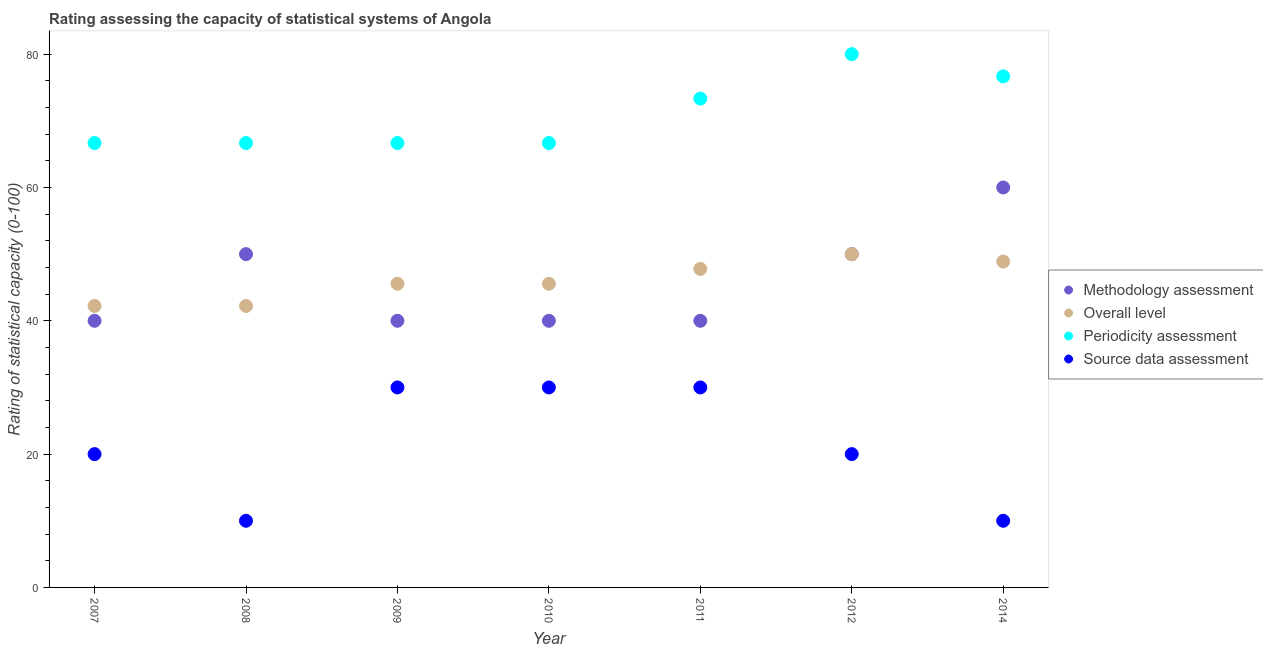How many different coloured dotlines are there?
Your response must be concise. 4. What is the methodology assessment rating in 2011?
Offer a terse response. 40. Across all years, what is the maximum source data assessment rating?
Ensure brevity in your answer.  30. Across all years, what is the minimum overall level rating?
Give a very brief answer. 42.22. In which year was the overall level rating maximum?
Provide a succinct answer. 2012. What is the total methodology assessment rating in the graph?
Offer a terse response. 320. What is the difference between the methodology assessment rating in 2011 and that in 2012?
Offer a very short reply. -10. What is the difference between the periodicity assessment rating in 2007 and the source data assessment rating in 2008?
Make the answer very short. 56.67. What is the average overall level rating per year?
Your answer should be compact. 46.03. In the year 2008, what is the difference between the overall level rating and methodology assessment rating?
Make the answer very short. -7.78. In how many years, is the periodicity assessment rating greater than 4?
Provide a short and direct response. 7. What is the ratio of the overall level rating in 2007 to that in 2009?
Provide a short and direct response. 0.93. Is the periodicity assessment rating in 2008 less than that in 2011?
Your response must be concise. Yes. Is the difference between the methodology assessment rating in 2011 and 2014 greater than the difference between the overall level rating in 2011 and 2014?
Provide a short and direct response. No. What is the difference between the highest and the lowest overall level rating?
Offer a terse response. 7.78. Is the sum of the overall level rating in 2008 and 2014 greater than the maximum periodicity assessment rating across all years?
Your answer should be compact. Yes. How many dotlines are there?
Offer a very short reply. 4. Does the graph contain any zero values?
Your answer should be very brief. No. Where does the legend appear in the graph?
Provide a succinct answer. Center right. How many legend labels are there?
Provide a succinct answer. 4. How are the legend labels stacked?
Provide a short and direct response. Vertical. What is the title of the graph?
Give a very brief answer. Rating assessing the capacity of statistical systems of Angola. Does "Corruption" appear as one of the legend labels in the graph?
Provide a succinct answer. No. What is the label or title of the Y-axis?
Your response must be concise. Rating of statistical capacity (0-100). What is the Rating of statistical capacity (0-100) in Methodology assessment in 2007?
Provide a short and direct response. 40. What is the Rating of statistical capacity (0-100) in Overall level in 2007?
Provide a succinct answer. 42.22. What is the Rating of statistical capacity (0-100) in Periodicity assessment in 2007?
Offer a very short reply. 66.67. What is the Rating of statistical capacity (0-100) of Overall level in 2008?
Make the answer very short. 42.22. What is the Rating of statistical capacity (0-100) in Periodicity assessment in 2008?
Give a very brief answer. 66.67. What is the Rating of statistical capacity (0-100) in Methodology assessment in 2009?
Make the answer very short. 40. What is the Rating of statistical capacity (0-100) in Overall level in 2009?
Your response must be concise. 45.56. What is the Rating of statistical capacity (0-100) in Periodicity assessment in 2009?
Your answer should be compact. 66.67. What is the Rating of statistical capacity (0-100) of Source data assessment in 2009?
Provide a short and direct response. 30. What is the Rating of statistical capacity (0-100) in Overall level in 2010?
Make the answer very short. 45.56. What is the Rating of statistical capacity (0-100) in Periodicity assessment in 2010?
Offer a terse response. 66.67. What is the Rating of statistical capacity (0-100) of Overall level in 2011?
Provide a succinct answer. 47.78. What is the Rating of statistical capacity (0-100) in Periodicity assessment in 2011?
Your answer should be very brief. 73.33. What is the Rating of statistical capacity (0-100) of Source data assessment in 2011?
Provide a short and direct response. 30. What is the Rating of statistical capacity (0-100) in Methodology assessment in 2012?
Provide a succinct answer. 50. What is the Rating of statistical capacity (0-100) in Periodicity assessment in 2012?
Keep it short and to the point. 80. What is the Rating of statistical capacity (0-100) of Methodology assessment in 2014?
Your answer should be compact. 60. What is the Rating of statistical capacity (0-100) in Overall level in 2014?
Ensure brevity in your answer.  48.89. What is the Rating of statistical capacity (0-100) of Periodicity assessment in 2014?
Ensure brevity in your answer.  76.67. Across all years, what is the maximum Rating of statistical capacity (0-100) of Methodology assessment?
Your answer should be compact. 60. Across all years, what is the minimum Rating of statistical capacity (0-100) of Methodology assessment?
Give a very brief answer. 40. Across all years, what is the minimum Rating of statistical capacity (0-100) of Overall level?
Provide a succinct answer. 42.22. Across all years, what is the minimum Rating of statistical capacity (0-100) of Periodicity assessment?
Make the answer very short. 66.67. Across all years, what is the minimum Rating of statistical capacity (0-100) in Source data assessment?
Ensure brevity in your answer.  10. What is the total Rating of statistical capacity (0-100) in Methodology assessment in the graph?
Offer a terse response. 320. What is the total Rating of statistical capacity (0-100) of Overall level in the graph?
Your answer should be compact. 322.22. What is the total Rating of statistical capacity (0-100) in Periodicity assessment in the graph?
Give a very brief answer. 496.67. What is the total Rating of statistical capacity (0-100) of Source data assessment in the graph?
Your answer should be very brief. 150. What is the difference between the Rating of statistical capacity (0-100) in Overall level in 2007 and that in 2008?
Make the answer very short. 0. What is the difference between the Rating of statistical capacity (0-100) in Source data assessment in 2007 and that in 2008?
Offer a terse response. 10. What is the difference between the Rating of statistical capacity (0-100) in Methodology assessment in 2007 and that in 2009?
Make the answer very short. 0. What is the difference between the Rating of statistical capacity (0-100) of Methodology assessment in 2007 and that in 2011?
Give a very brief answer. 0. What is the difference between the Rating of statistical capacity (0-100) of Overall level in 2007 and that in 2011?
Provide a short and direct response. -5.56. What is the difference between the Rating of statistical capacity (0-100) in Periodicity assessment in 2007 and that in 2011?
Your response must be concise. -6.67. What is the difference between the Rating of statistical capacity (0-100) of Source data assessment in 2007 and that in 2011?
Provide a short and direct response. -10. What is the difference between the Rating of statistical capacity (0-100) of Methodology assessment in 2007 and that in 2012?
Your answer should be very brief. -10. What is the difference between the Rating of statistical capacity (0-100) in Overall level in 2007 and that in 2012?
Keep it short and to the point. -7.78. What is the difference between the Rating of statistical capacity (0-100) of Periodicity assessment in 2007 and that in 2012?
Give a very brief answer. -13.33. What is the difference between the Rating of statistical capacity (0-100) in Source data assessment in 2007 and that in 2012?
Provide a short and direct response. 0. What is the difference between the Rating of statistical capacity (0-100) in Overall level in 2007 and that in 2014?
Provide a short and direct response. -6.67. What is the difference between the Rating of statistical capacity (0-100) of Source data assessment in 2007 and that in 2014?
Your answer should be very brief. 10. What is the difference between the Rating of statistical capacity (0-100) in Methodology assessment in 2008 and that in 2009?
Provide a succinct answer. 10. What is the difference between the Rating of statistical capacity (0-100) in Overall level in 2008 and that in 2009?
Keep it short and to the point. -3.33. What is the difference between the Rating of statistical capacity (0-100) of Methodology assessment in 2008 and that in 2010?
Offer a terse response. 10. What is the difference between the Rating of statistical capacity (0-100) of Overall level in 2008 and that in 2010?
Keep it short and to the point. -3.33. What is the difference between the Rating of statistical capacity (0-100) of Periodicity assessment in 2008 and that in 2010?
Your answer should be very brief. 0. What is the difference between the Rating of statistical capacity (0-100) of Overall level in 2008 and that in 2011?
Offer a terse response. -5.56. What is the difference between the Rating of statistical capacity (0-100) of Periodicity assessment in 2008 and that in 2011?
Keep it short and to the point. -6.67. What is the difference between the Rating of statistical capacity (0-100) of Methodology assessment in 2008 and that in 2012?
Ensure brevity in your answer.  0. What is the difference between the Rating of statistical capacity (0-100) of Overall level in 2008 and that in 2012?
Provide a succinct answer. -7.78. What is the difference between the Rating of statistical capacity (0-100) in Periodicity assessment in 2008 and that in 2012?
Your answer should be very brief. -13.33. What is the difference between the Rating of statistical capacity (0-100) of Overall level in 2008 and that in 2014?
Provide a succinct answer. -6.67. What is the difference between the Rating of statistical capacity (0-100) of Periodicity assessment in 2008 and that in 2014?
Give a very brief answer. -10. What is the difference between the Rating of statistical capacity (0-100) in Source data assessment in 2008 and that in 2014?
Your answer should be very brief. 0. What is the difference between the Rating of statistical capacity (0-100) of Methodology assessment in 2009 and that in 2010?
Provide a succinct answer. 0. What is the difference between the Rating of statistical capacity (0-100) of Periodicity assessment in 2009 and that in 2010?
Offer a very short reply. 0. What is the difference between the Rating of statistical capacity (0-100) in Overall level in 2009 and that in 2011?
Offer a terse response. -2.22. What is the difference between the Rating of statistical capacity (0-100) of Periodicity assessment in 2009 and that in 2011?
Your response must be concise. -6.67. What is the difference between the Rating of statistical capacity (0-100) in Source data assessment in 2009 and that in 2011?
Keep it short and to the point. 0. What is the difference between the Rating of statistical capacity (0-100) of Overall level in 2009 and that in 2012?
Provide a short and direct response. -4.44. What is the difference between the Rating of statistical capacity (0-100) of Periodicity assessment in 2009 and that in 2012?
Keep it short and to the point. -13.33. What is the difference between the Rating of statistical capacity (0-100) of Overall level in 2009 and that in 2014?
Your answer should be very brief. -3.33. What is the difference between the Rating of statistical capacity (0-100) in Periodicity assessment in 2009 and that in 2014?
Keep it short and to the point. -10. What is the difference between the Rating of statistical capacity (0-100) of Methodology assessment in 2010 and that in 2011?
Ensure brevity in your answer.  0. What is the difference between the Rating of statistical capacity (0-100) in Overall level in 2010 and that in 2011?
Offer a very short reply. -2.22. What is the difference between the Rating of statistical capacity (0-100) of Periodicity assessment in 2010 and that in 2011?
Make the answer very short. -6.67. What is the difference between the Rating of statistical capacity (0-100) of Methodology assessment in 2010 and that in 2012?
Your answer should be compact. -10. What is the difference between the Rating of statistical capacity (0-100) of Overall level in 2010 and that in 2012?
Give a very brief answer. -4.44. What is the difference between the Rating of statistical capacity (0-100) in Periodicity assessment in 2010 and that in 2012?
Your answer should be very brief. -13.33. What is the difference between the Rating of statistical capacity (0-100) of Overall level in 2010 and that in 2014?
Your answer should be compact. -3.33. What is the difference between the Rating of statistical capacity (0-100) in Overall level in 2011 and that in 2012?
Your answer should be very brief. -2.22. What is the difference between the Rating of statistical capacity (0-100) in Periodicity assessment in 2011 and that in 2012?
Keep it short and to the point. -6.67. What is the difference between the Rating of statistical capacity (0-100) of Overall level in 2011 and that in 2014?
Offer a terse response. -1.11. What is the difference between the Rating of statistical capacity (0-100) in Overall level in 2012 and that in 2014?
Your answer should be compact. 1.11. What is the difference between the Rating of statistical capacity (0-100) of Methodology assessment in 2007 and the Rating of statistical capacity (0-100) of Overall level in 2008?
Keep it short and to the point. -2.22. What is the difference between the Rating of statistical capacity (0-100) of Methodology assessment in 2007 and the Rating of statistical capacity (0-100) of Periodicity assessment in 2008?
Your response must be concise. -26.67. What is the difference between the Rating of statistical capacity (0-100) of Overall level in 2007 and the Rating of statistical capacity (0-100) of Periodicity assessment in 2008?
Make the answer very short. -24.44. What is the difference between the Rating of statistical capacity (0-100) in Overall level in 2007 and the Rating of statistical capacity (0-100) in Source data assessment in 2008?
Provide a short and direct response. 32.22. What is the difference between the Rating of statistical capacity (0-100) of Periodicity assessment in 2007 and the Rating of statistical capacity (0-100) of Source data assessment in 2008?
Give a very brief answer. 56.67. What is the difference between the Rating of statistical capacity (0-100) of Methodology assessment in 2007 and the Rating of statistical capacity (0-100) of Overall level in 2009?
Provide a succinct answer. -5.56. What is the difference between the Rating of statistical capacity (0-100) of Methodology assessment in 2007 and the Rating of statistical capacity (0-100) of Periodicity assessment in 2009?
Offer a very short reply. -26.67. What is the difference between the Rating of statistical capacity (0-100) of Methodology assessment in 2007 and the Rating of statistical capacity (0-100) of Source data assessment in 2009?
Offer a terse response. 10. What is the difference between the Rating of statistical capacity (0-100) of Overall level in 2007 and the Rating of statistical capacity (0-100) of Periodicity assessment in 2009?
Make the answer very short. -24.44. What is the difference between the Rating of statistical capacity (0-100) in Overall level in 2007 and the Rating of statistical capacity (0-100) in Source data assessment in 2009?
Provide a short and direct response. 12.22. What is the difference between the Rating of statistical capacity (0-100) in Periodicity assessment in 2007 and the Rating of statistical capacity (0-100) in Source data assessment in 2009?
Ensure brevity in your answer.  36.67. What is the difference between the Rating of statistical capacity (0-100) of Methodology assessment in 2007 and the Rating of statistical capacity (0-100) of Overall level in 2010?
Offer a very short reply. -5.56. What is the difference between the Rating of statistical capacity (0-100) of Methodology assessment in 2007 and the Rating of statistical capacity (0-100) of Periodicity assessment in 2010?
Keep it short and to the point. -26.67. What is the difference between the Rating of statistical capacity (0-100) of Overall level in 2007 and the Rating of statistical capacity (0-100) of Periodicity assessment in 2010?
Your answer should be very brief. -24.44. What is the difference between the Rating of statistical capacity (0-100) of Overall level in 2007 and the Rating of statistical capacity (0-100) of Source data assessment in 2010?
Your answer should be very brief. 12.22. What is the difference between the Rating of statistical capacity (0-100) in Periodicity assessment in 2007 and the Rating of statistical capacity (0-100) in Source data assessment in 2010?
Your response must be concise. 36.67. What is the difference between the Rating of statistical capacity (0-100) of Methodology assessment in 2007 and the Rating of statistical capacity (0-100) of Overall level in 2011?
Give a very brief answer. -7.78. What is the difference between the Rating of statistical capacity (0-100) of Methodology assessment in 2007 and the Rating of statistical capacity (0-100) of Periodicity assessment in 2011?
Your response must be concise. -33.33. What is the difference between the Rating of statistical capacity (0-100) in Methodology assessment in 2007 and the Rating of statistical capacity (0-100) in Source data assessment in 2011?
Give a very brief answer. 10. What is the difference between the Rating of statistical capacity (0-100) in Overall level in 2007 and the Rating of statistical capacity (0-100) in Periodicity assessment in 2011?
Your answer should be very brief. -31.11. What is the difference between the Rating of statistical capacity (0-100) of Overall level in 2007 and the Rating of statistical capacity (0-100) of Source data assessment in 2011?
Offer a very short reply. 12.22. What is the difference between the Rating of statistical capacity (0-100) of Periodicity assessment in 2007 and the Rating of statistical capacity (0-100) of Source data assessment in 2011?
Make the answer very short. 36.67. What is the difference between the Rating of statistical capacity (0-100) in Overall level in 2007 and the Rating of statistical capacity (0-100) in Periodicity assessment in 2012?
Keep it short and to the point. -37.78. What is the difference between the Rating of statistical capacity (0-100) of Overall level in 2007 and the Rating of statistical capacity (0-100) of Source data assessment in 2012?
Make the answer very short. 22.22. What is the difference between the Rating of statistical capacity (0-100) in Periodicity assessment in 2007 and the Rating of statistical capacity (0-100) in Source data assessment in 2012?
Ensure brevity in your answer.  46.67. What is the difference between the Rating of statistical capacity (0-100) of Methodology assessment in 2007 and the Rating of statistical capacity (0-100) of Overall level in 2014?
Provide a succinct answer. -8.89. What is the difference between the Rating of statistical capacity (0-100) in Methodology assessment in 2007 and the Rating of statistical capacity (0-100) in Periodicity assessment in 2014?
Offer a very short reply. -36.67. What is the difference between the Rating of statistical capacity (0-100) of Overall level in 2007 and the Rating of statistical capacity (0-100) of Periodicity assessment in 2014?
Your answer should be very brief. -34.44. What is the difference between the Rating of statistical capacity (0-100) of Overall level in 2007 and the Rating of statistical capacity (0-100) of Source data assessment in 2014?
Keep it short and to the point. 32.22. What is the difference between the Rating of statistical capacity (0-100) in Periodicity assessment in 2007 and the Rating of statistical capacity (0-100) in Source data assessment in 2014?
Give a very brief answer. 56.67. What is the difference between the Rating of statistical capacity (0-100) in Methodology assessment in 2008 and the Rating of statistical capacity (0-100) in Overall level in 2009?
Provide a short and direct response. 4.44. What is the difference between the Rating of statistical capacity (0-100) in Methodology assessment in 2008 and the Rating of statistical capacity (0-100) in Periodicity assessment in 2009?
Your answer should be very brief. -16.67. What is the difference between the Rating of statistical capacity (0-100) in Overall level in 2008 and the Rating of statistical capacity (0-100) in Periodicity assessment in 2009?
Ensure brevity in your answer.  -24.44. What is the difference between the Rating of statistical capacity (0-100) of Overall level in 2008 and the Rating of statistical capacity (0-100) of Source data assessment in 2009?
Keep it short and to the point. 12.22. What is the difference between the Rating of statistical capacity (0-100) in Periodicity assessment in 2008 and the Rating of statistical capacity (0-100) in Source data assessment in 2009?
Make the answer very short. 36.67. What is the difference between the Rating of statistical capacity (0-100) in Methodology assessment in 2008 and the Rating of statistical capacity (0-100) in Overall level in 2010?
Offer a very short reply. 4.44. What is the difference between the Rating of statistical capacity (0-100) of Methodology assessment in 2008 and the Rating of statistical capacity (0-100) of Periodicity assessment in 2010?
Your response must be concise. -16.67. What is the difference between the Rating of statistical capacity (0-100) of Methodology assessment in 2008 and the Rating of statistical capacity (0-100) of Source data assessment in 2010?
Offer a terse response. 20. What is the difference between the Rating of statistical capacity (0-100) of Overall level in 2008 and the Rating of statistical capacity (0-100) of Periodicity assessment in 2010?
Your answer should be very brief. -24.44. What is the difference between the Rating of statistical capacity (0-100) in Overall level in 2008 and the Rating of statistical capacity (0-100) in Source data assessment in 2010?
Give a very brief answer. 12.22. What is the difference between the Rating of statistical capacity (0-100) in Periodicity assessment in 2008 and the Rating of statistical capacity (0-100) in Source data assessment in 2010?
Your response must be concise. 36.67. What is the difference between the Rating of statistical capacity (0-100) of Methodology assessment in 2008 and the Rating of statistical capacity (0-100) of Overall level in 2011?
Your answer should be very brief. 2.22. What is the difference between the Rating of statistical capacity (0-100) of Methodology assessment in 2008 and the Rating of statistical capacity (0-100) of Periodicity assessment in 2011?
Make the answer very short. -23.33. What is the difference between the Rating of statistical capacity (0-100) in Overall level in 2008 and the Rating of statistical capacity (0-100) in Periodicity assessment in 2011?
Your answer should be compact. -31.11. What is the difference between the Rating of statistical capacity (0-100) of Overall level in 2008 and the Rating of statistical capacity (0-100) of Source data assessment in 2011?
Your answer should be compact. 12.22. What is the difference between the Rating of statistical capacity (0-100) in Periodicity assessment in 2008 and the Rating of statistical capacity (0-100) in Source data assessment in 2011?
Provide a short and direct response. 36.67. What is the difference between the Rating of statistical capacity (0-100) of Methodology assessment in 2008 and the Rating of statistical capacity (0-100) of Periodicity assessment in 2012?
Provide a succinct answer. -30. What is the difference between the Rating of statistical capacity (0-100) of Overall level in 2008 and the Rating of statistical capacity (0-100) of Periodicity assessment in 2012?
Provide a succinct answer. -37.78. What is the difference between the Rating of statistical capacity (0-100) of Overall level in 2008 and the Rating of statistical capacity (0-100) of Source data assessment in 2012?
Give a very brief answer. 22.22. What is the difference between the Rating of statistical capacity (0-100) of Periodicity assessment in 2008 and the Rating of statistical capacity (0-100) of Source data assessment in 2012?
Keep it short and to the point. 46.67. What is the difference between the Rating of statistical capacity (0-100) of Methodology assessment in 2008 and the Rating of statistical capacity (0-100) of Overall level in 2014?
Ensure brevity in your answer.  1.11. What is the difference between the Rating of statistical capacity (0-100) of Methodology assessment in 2008 and the Rating of statistical capacity (0-100) of Periodicity assessment in 2014?
Your answer should be very brief. -26.67. What is the difference between the Rating of statistical capacity (0-100) of Methodology assessment in 2008 and the Rating of statistical capacity (0-100) of Source data assessment in 2014?
Your response must be concise. 40. What is the difference between the Rating of statistical capacity (0-100) in Overall level in 2008 and the Rating of statistical capacity (0-100) in Periodicity assessment in 2014?
Give a very brief answer. -34.44. What is the difference between the Rating of statistical capacity (0-100) in Overall level in 2008 and the Rating of statistical capacity (0-100) in Source data assessment in 2014?
Your answer should be very brief. 32.22. What is the difference between the Rating of statistical capacity (0-100) of Periodicity assessment in 2008 and the Rating of statistical capacity (0-100) of Source data assessment in 2014?
Give a very brief answer. 56.67. What is the difference between the Rating of statistical capacity (0-100) of Methodology assessment in 2009 and the Rating of statistical capacity (0-100) of Overall level in 2010?
Ensure brevity in your answer.  -5.56. What is the difference between the Rating of statistical capacity (0-100) of Methodology assessment in 2009 and the Rating of statistical capacity (0-100) of Periodicity assessment in 2010?
Provide a succinct answer. -26.67. What is the difference between the Rating of statistical capacity (0-100) of Overall level in 2009 and the Rating of statistical capacity (0-100) of Periodicity assessment in 2010?
Give a very brief answer. -21.11. What is the difference between the Rating of statistical capacity (0-100) of Overall level in 2009 and the Rating of statistical capacity (0-100) of Source data assessment in 2010?
Ensure brevity in your answer.  15.56. What is the difference between the Rating of statistical capacity (0-100) in Periodicity assessment in 2009 and the Rating of statistical capacity (0-100) in Source data assessment in 2010?
Offer a terse response. 36.67. What is the difference between the Rating of statistical capacity (0-100) in Methodology assessment in 2009 and the Rating of statistical capacity (0-100) in Overall level in 2011?
Ensure brevity in your answer.  -7.78. What is the difference between the Rating of statistical capacity (0-100) in Methodology assessment in 2009 and the Rating of statistical capacity (0-100) in Periodicity assessment in 2011?
Keep it short and to the point. -33.33. What is the difference between the Rating of statistical capacity (0-100) in Methodology assessment in 2009 and the Rating of statistical capacity (0-100) in Source data assessment in 2011?
Your response must be concise. 10. What is the difference between the Rating of statistical capacity (0-100) of Overall level in 2009 and the Rating of statistical capacity (0-100) of Periodicity assessment in 2011?
Ensure brevity in your answer.  -27.78. What is the difference between the Rating of statistical capacity (0-100) in Overall level in 2009 and the Rating of statistical capacity (0-100) in Source data assessment in 2011?
Offer a terse response. 15.56. What is the difference between the Rating of statistical capacity (0-100) in Periodicity assessment in 2009 and the Rating of statistical capacity (0-100) in Source data assessment in 2011?
Give a very brief answer. 36.67. What is the difference between the Rating of statistical capacity (0-100) of Overall level in 2009 and the Rating of statistical capacity (0-100) of Periodicity assessment in 2012?
Make the answer very short. -34.44. What is the difference between the Rating of statistical capacity (0-100) in Overall level in 2009 and the Rating of statistical capacity (0-100) in Source data assessment in 2012?
Your answer should be very brief. 25.56. What is the difference between the Rating of statistical capacity (0-100) in Periodicity assessment in 2009 and the Rating of statistical capacity (0-100) in Source data assessment in 2012?
Your answer should be very brief. 46.67. What is the difference between the Rating of statistical capacity (0-100) in Methodology assessment in 2009 and the Rating of statistical capacity (0-100) in Overall level in 2014?
Ensure brevity in your answer.  -8.89. What is the difference between the Rating of statistical capacity (0-100) of Methodology assessment in 2009 and the Rating of statistical capacity (0-100) of Periodicity assessment in 2014?
Offer a very short reply. -36.67. What is the difference between the Rating of statistical capacity (0-100) in Overall level in 2009 and the Rating of statistical capacity (0-100) in Periodicity assessment in 2014?
Ensure brevity in your answer.  -31.11. What is the difference between the Rating of statistical capacity (0-100) in Overall level in 2009 and the Rating of statistical capacity (0-100) in Source data assessment in 2014?
Make the answer very short. 35.56. What is the difference between the Rating of statistical capacity (0-100) of Periodicity assessment in 2009 and the Rating of statistical capacity (0-100) of Source data assessment in 2014?
Provide a succinct answer. 56.67. What is the difference between the Rating of statistical capacity (0-100) in Methodology assessment in 2010 and the Rating of statistical capacity (0-100) in Overall level in 2011?
Your answer should be very brief. -7.78. What is the difference between the Rating of statistical capacity (0-100) in Methodology assessment in 2010 and the Rating of statistical capacity (0-100) in Periodicity assessment in 2011?
Provide a succinct answer. -33.33. What is the difference between the Rating of statistical capacity (0-100) of Overall level in 2010 and the Rating of statistical capacity (0-100) of Periodicity assessment in 2011?
Keep it short and to the point. -27.78. What is the difference between the Rating of statistical capacity (0-100) in Overall level in 2010 and the Rating of statistical capacity (0-100) in Source data assessment in 2011?
Offer a terse response. 15.56. What is the difference between the Rating of statistical capacity (0-100) in Periodicity assessment in 2010 and the Rating of statistical capacity (0-100) in Source data assessment in 2011?
Make the answer very short. 36.67. What is the difference between the Rating of statistical capacity (0-100) in Methodology assessment in 2010 and the Rating of statistical capacity (0-100) in Overall level in 2012?
Provide a succinct answer. -10. What is the difference between the Rating of statistical capacity (0-100) in Overall level in 2010 and the Rating of statistical capacity (0-100) in Periodicity assessment in 2012?
Give a very brief answer. -34.44. What is the difference between the Rating of statistical capacity (0-100) of Overall level in 2010 and the Rating of statistical capacity (0-100) of Source data assessment in 2012?
Give a very brief answer. 25.56. What is the difference between the Rating of statistical capacity (0-100) in Periodicity assessment in 2010 and the Rating of statistical capacity (0-100) in Source data assessment in 2012?
Provide a succinct answer. 46.67. What is the difference between the Rating of statistical capacity (0-100) in Methodology assessment in 2010 and the Rating of statistical capacity (0-100) in Overall level in 2014?
Keep it short and to the point. -8.89. What is the difference between the Rating of statistical capacity (0-100) of Methodology assessment in 2010 and the Rating of statistical capacity (0-100) of Periodicity assessment in 2014?
Give a very brief answer. -36.67. What is the difference between the Rating of statistical capacity (0-100) in Methodology assessment in 2010 and the Rating of statistical capacity (0-100) in Source data assessment in 2014?
Offer a very short reply. 30. What is the difference between the Rating of statistical capacity (0-100) of Overall level in 2010 and the Rating of statistical capacity (0-100) of Periodicity assessment in 2014?
Make the answer very short. -31.11. What is the difference between the Rating of statistical capacity (0-100) in Overall level in 2010 and the Rating of statistical capacity (0-100) in Source data assessment in 2014?
Make the answer very short. 35.56. What is the difference between the Rating of statistical capacity (0-100) in Periodicity assessment in 2010 and the Rating of statistical capacity (0-100) in Source data assessment in 2014?
Ensure brevity in your answer.  56.67. What is the difference between the Rating of statistical capacity (0-100) of Methodology assessment in 2011 and the Rating of statistical capacity (0-100) of Overall level in 2012?
Offer a very short reply. -10. What is the difference between the Rating of statistical capacity (0-100) in Methodology assessment in 2011 and the Rating of statistical capacity (0-100) in Source data assessment in 2012?
Offer a very short reply. 20. What is the difference between the Rating of statistical capacity (0-100) in Overall level in 2011 and the Rating of statistical capacity (0-100) in Periodicity assessment in 2012?
Make the answer very short. -32.22. What is the difference between the Rating of statistical capacity (0-100) in Overall level in 2011 and the Rating of statistical capacity (0-100) in Source data assessment in 2012?
Give a very brief answer. 27.78. What is the difference between the Rating of statistical capacity (0-100) in Periodicity assessment in 2011 and the Rating of statistical capacity (0-100) in Source data assessment in 2012?
Provide a succinct answer. 53.33. What is the difference between the Rating of statistical capacity (0-100) of Methodology assessment in 2011 and the Rating of statistical capacity (0-100) of Overall level in 2014?
Make the answer very short. -8.89. What is the difference between the Rating of statistical capacity (0-100) of Methodology assessment in 2011 and the Rating of statistical capacity (0-100) of Periodicity assessment in 2014?
Provide a short and direct response. -36.67. What is the difference between the Rating of statistical capacity (0-100) of Overall level in 2011 and the Rating of statistical capacity (0-100) of Periodicity assessment in 2014?
Your response must be concise. -28.89. What is the difference between the Rating of statistical capacity (0-100) of Overall level in 2011 and the Rating of statistical capacity (0-100) of Source data assessment in 2014?
Provide a short and direct response. 37.78. What is the difference between the Rating of statistical capacity (0-100) in Periodicity assessment in 2011 and the Rating of statistical capacity (0-100) in Source data assessment in 2014?
Keep it short and to the point. 63.33. What is the difference between the Rating of statistical capacity (0-100) of Methodology assessment in 2012 and the Rating of statistical capacity (0-100) of Periodicity assessment in 2014?
Offer a very short reply. -26.67. What is the difference between the Rating of statistical capacity (0-100) in Overall level in 2012 and the Rating of statistical capacity (0-100) in Periodicity assessment in 2014?
Ensure brevity in your answer.  -26.67. What is the difference between the Rating of statistical capacity (0-100) of Periodicity assessment in 2012 and the Rating of statistical capacity (0-100) of Source data assessment in 2014?
Your response must be concise. 70. What is the average Rating of statistical capacity (0-100) of Methodology assessment per year?
Provide a succinct answer. 45.71. What is the average Rating of statistical capacity (0-100) in Overall level per year?
Your response must be concise. 46.03. What is the average Rating of statistical capacity (0-100) in Periodicity assessment per year?
Make the answer very short. 70.95. What is the average Rating of statistical capacity (0-100) in Source data assessment per year?
Ensure brevity in your answer.  21.43. In the year 2007, what is the difference between the Rating of statistical capacity (0-100) in Methodology assessment and Rating of statistical capacity (0-100) in Overall level?
Offer a terse response. -2.22. In the year 2007, what is the difference between the Rating of statistical capacity (0-100) of Methodology assessment and Rating of statistical capacity (0-100) of Periodicity assessment?
Give a very brief answer. -26.67. In the year 2007, what is the difference between the Rating of statistical capacity (0-100) of Overall level and Rating of statistical capacity (0-100) of Periodicity assessment?
Give a very brief answer. -24.44. In the year 2007, what is the difference between the Rating of statistical capacity (0-100) of Overall level and Rating of statistical capacity (0-100) of Source data assessment?
Your answer should be compact. 22.22. In the year 2007, what is the difference between the Rating of statistical capacity (0-100) of Periodicity assessment and Rating of statistical capacity (0-100) of Source data assessment?
Provide a short and direct response. 46.67. In the year 2008, what is the difference between the Rating of statistical capacity (0-100) in Methodology assessment and Rating of statistical capacity (0-100) in Overall level?
Your response must be concise. 7.78. In the year 2008, what is the difference between the Rating of statistical capacity (0-100) of Methodology assessment and Rating of statistical capacity (0-100) of Periodicity assessment?
Offer a terse response. -16.67. In the year 2008, what is the difference between the Rating of statistical capacity (0-100) of Methodology assessment and Rating of statistical capacity (0-100) of Source data assessment?
Ensure brevity in your answer.  40. In the year 2008, what is the difference between the Rating of statistical capacity (0-100) of Overall level and Rating of statistical capacity (0-100) of Periodicity assessment?
Give a very brief answer. -24.44. In the year 2008, what is the difference between the Rating of statistical capacity (0-100) in Overall level and Rating of statistical capacity (0-100) in Source data assessment?
Keep it short and to the point. 32.22. In the year 2008, what is the difference between the Rating of statistical capacity (0-100) of Periodicity assessment and Rating of statistical capacity (0-100) of Source data assessment?
Make the answer very short. 56.67. In the year 2009, what is the difference between the Rating of statistical capacity (0-100) of Methodology assessment and Rating of statistical capacity (0-100) of Overall level?
Make the answer very short. -5.56. In the year 2009, what is the difference between the Rating of statistical capacity (0-100) in Methodology assessment and Rating of statistical capacity (0-100) in Periodicity assessment?
Your answer should be compact. -26.67. In the year 2009, what is the difference between the Rating of statistical capacity (0-100) in Overall level and Rating of statistical capacity (0-100) in Periodicity assessment?
Ensure brevity in your answer.  -21.11. In the year 2009, what is the difference between the Rating of statistical capacity (0-100) in Overall level and Rating of statistical capacity (0-100) in Source data assessment?
Offer a very short reply. 15.56. In the year 2009, what is the difference between the Rating of statistical capacity (0-100) of Periodicity assessment and Rating of statistical capacity (0-100) of Source data assessment?
Your answer should be compact. 36.67. In the year 2010, what is the difference between the Rating of statistical capacity (0-100) in Methodology assessment and Rating of statistical capacity (0-100) in Overall level?
Your answer should be very brief. -5.56. In the year 2010, what is the difference between the Rating of statistical capacity (0-100) in Methodology assessment and Rating of statistical capacity (0-100) in Periodicity assessment?
Offer a very short reply. -26.67. In the year 2010, what is the difference between the Rating of statistical capacity (0-100) in Methodology assessment and Rating of statistical capacity (0-100) in Source data assessment?
Offer a very short reply. 10. In the year 2010, what is the difference between the Rating of statistical capacity (0-100) of Overall level and Rating of statistical capacity (0-100) of Periodicity assessment?
Offer a terse response. -21.11. In the year 2010, what is the difference between the Rating of statistical capacity (0-100) in Overall level and Rating of statistical capacity (0-100) in Source data assessment?
Ensure brevity in your answer.  15.56. In the year 2010, what is the difference between the Rating of statistical capacity (0-100) in Periodicity assessment and Rating of statistical capacity (0-100) in Source data assessment?
Your response must be concise. 36.67. In the year 2011, what is the difference between the Rating of statistical capacity (0-100) of Methodology assessment and Rating of statistical capacity (0-100) of Overall level?
Offer a very short reply. -7.78. In the year 2011, what is the difference between the Rating of statistical capacity (0-100) in Methodology assessment and Rating of statistical capacity (0-100) in Periodicity assessment?
Make the answer very short. -33.33. In the year 2011, what is the difference between the Rating of statistical capacity (0-100) of Methodology assessment and Rating of statistical capacity (0-100) of Source data assessment?
Ensure brevity in your answer.  10. In the year 2011, what is the difference between the Rating of statistical capacity (0-100) of Overall level and Rating of statistical capacity (0-100) of Periodicity assessment?
Make the answer very short. -25.56. In the year 2011, what is the difference between the Rating of statistical capacity (0-100) in Overall level and Rating of statistical capacity (0-100) in Source data assessment?
Provide a succinct answer. 17.78. In the year 2011, what is the difference between the Rating of statistical capacity (0-100) of Periodicity assessment and Rating of statistical capacity (0-100) of Source data assessment?
Provide a short and direct response. 43.33. In the year 2014, what is the difference between the Rating of statistical capacity (0-100) of Methodology assessment and Rating of statistical capacity (0-100) of Overall level?
Offer a terse response. 11.11. In the year 2014, what is the difference between the Rating of statistical capacity (0-100) in Methodology assessment and Rating of statistical capacity (0-100) in Periodicity assessment?
Provide a short and direct response. -16.67. In the year 2014, what is the difference between the Rating of statistical capacity (0-100) in Methodology assessment and Rating of statistical capacity (0-100) in Source data assessment?
Keep it short and to the point. 50. In the year 2014, what is the difference between the Rating of statistical capacity (0-100) of Overall level and Rating of statistical capacity (0-100) of Periodicity assessment?
Your answer should be very brief. -27.78. In the year 2014, what is the difference between the Rating of statistical capacity (0-100) in Overall level and Rating of statistical capacity (0-100) in Source data assessment?
Offer a terse response. 38.89. In the year 2014, what is the difference between the Rating of statistical capacity (0-100) in Periodicity assessment and Rating of statistical capacity (0-100) in Source data assessment?
Offer a very short reply. 66.67. What is the ratio of the Rating of statistical capacity (0-100) of Methodology assessment in 2007 to that in 2008?
Your response must be concise. 0.8. What is the ratio of the Rating of statistical capacity (0-100) of Overall level in 2007 to that in 2008?
Your answer should be compact. 1. What is the ratio of the Rating of statistical capacity (0-100) in Periodicity assessment in 2007 to that in 2008?
Offer a terse response. 1. What is the ratio of the Rating of statistical capacity (0-100) in Source data assessment in 2007 to that in 2008?
Provide a short and direct response. 2. What is the ratio of the Rating of statistical capacity (0-100) in Overall level in 2007 to that in 2009?
Provide a succinct answer. 0.93. What is the ratio of the Rating of statistical capacity (0-100) in Periodicity assessment in 2007 to that in 2009?
Your answer should be very brief. 1. What is the ratio of the Rating of statistical capacity (0-100) in Source data assessment in 2007 to that in 2009?
Provide a short and direct response. 0.67. What is the ratio of the Rating of statistical capacity (0-100) in Methodology assessment in 2007 to that in 2010?
Give a very brief answer. 1. What is the ratio of the Rating of statistical capacity (0-100) of Overall level in 2007 to that in 2010?
Provide a short and direct response. 0.93. What is the ratio of the Rating of statistical capacity (0-100) of Periodicity assessment in 2007 to that in 2010?
Your response must be concise. 1. What is the ratio of the Rating of statistical capacity (0-100) of Source data assessment in 2007 to that in 2010?
Provide a short and direct response. 0.67. What is the ratio of the Rating of statistical capacity (0-100) of Methodology assessment in 2007 to that in 2011?
Make the answer very short. 1. What is the ratio of the Rating of statistical capacity (0-100) of Overall level in 2007 to that in 2011?
Provide a succinct answer. 0.88. What is the ratio of the Rating of statistical capacity (0-100) of Periodicity assessment in 2007 to that in 2011?
Offer a very short reply. 0.91. What is the ratio of the Rating of statistical capacity (0-100) of Source data assessment in 2007 to that in 2011?
Keep it short and to the point. 0.67. What is the ratio of the Rating of statistical capacity (0-100) in Methodology assessment in 2007 to that in 2012?
Offer a terse response. 0.8. What is the ratio of the Rating of statistical capacity (0-100) in Overall level in 2007 to that in 2012?
Offer a very short reply. 0.84. What is the ratio of the Rating of statistical capacity (0-100) of Periodicity assessment in 2007 to that in 2012?
Your answer should be very brief. 0.83. What is the ratio of the Rating of statistical capacity (0-100) in Overall level in 2007 to that in 2014?
Make the answer very short. 0.86. What is the ratio of the Rating of statistical capacity (0-100) of Periodicity assessment in 2007 to that in 2014?
Ensure brevity in your answer.  0.87. What is the ratio of the Rating of statistical capacity (0-100) of Overall level in 2008 to that in 2009?
Keep it short and to the point. 0.93. What is the ratio of the Rating of statistical capacity (0-100) of Periodicity assessment in 2008 to that in 2009?
Make the answer very short. 1. What is the ratio of the Rating of statistical capacity (0-100) of Methodology assessment in 2008 to that in 2010?
Your answer should be very brief. 1.25. What is the ratio of the Rating of statistical capacity (0-100) in Overall level in 2008 to that in 2010?
Give a very brief answer. 0.93. What is the ratio of the Rating of statistical capacity (0-100) in Periodicity assessment in 2008 to that in 2010?
Provide a short and direct response. 1. What is the ratio of the Rating of statistical capacity (0-100) in Source data assessment in 2008 to that in 2010?
Provide a short and direct response. 0.33. What is the ratio of the Rating of statistical capacity (0-100) of Methodology assessment in 2008 to that in 2011?
Make the answer very short. 1.25. What is the ratio of the Rating of statistical capacity (0-100) in Overall level in 2008 to that in 2011?
Provide a succinct answer. 0.88. What is the ratio of the Rating of statistical capacity (0-100) in Periodicity assessment in 2008 to that in 2011?
Give a very brief answer. 0.91. What is the ratio of the Rating of statistical capacity (0-100) of Overall level in 2008 to that in 2012?
Your answer should be very brief. 0.84. What is the ratio of the Rating of statistical capacity (0-100) of Methodology assessment in 2008 to that in 2014?
Give a very brief answer. 0.83. What is the ratio of the Rating of statistical capacity (0-100) in Overall level in 2008 to that in 2014?
Offer a terse response. 0.86. What is the ratio of the Rating of statistical capacity (0-100) in Periodicity assessment in 2008 to that in 2014?
Provide a succinct answer. 0.87. What is the ratio of the Rating of statistical capacity (0-100) of Methodology assessment in 2009 to that in 2010?
Offer a very short reply. 1. What is the ratio of the Rating of statistical capacity (0-100) in Periodicity assessment in 2009 to that in 2010?
Your response must be concise. 1. What is the ratio of the Rating of statistical capacity (0-100) of Methodology assessment in 2009 to that in 2011?
Provide a succinct answer. 1. What is the ratio of the Rating of statistical capacity (0-100) in Overall level in 2009 to that in 2011?
Your answer should be very brief. 0.95. What is the ratio of the Rating of statistical capacity (0-100) in Overall level in 2009 to that in 2012?
Keep it short and to the point. 0.91. What is the ratio of the Rating of statistical capacity (0-100) of Periodicity assessment in 2009 to that in 2012?
Ensure brevity in your answer.  0.83. What is the ratio of the Rating of statistical capacity (0-100) of Overall level in 2009 to that in 2014?
Ensure brevity in your answer.  0.93. What is the ratio of the Rating of statistical capacity (0-100) in Periodicity assessment in 2009 to that in 2014?
Your response must be concise. 0.87. What is the ratio of the Rating of statistical capacity (0-100) of Source data assessment in 2009 to that in 2014?
Offer a very short reply. 3. What is the ratio of the Rating of statistical capacity (0-100) of Methodology assessment in 2010 to that in 2011?
Offer a very short reply. 1. What is the ratio of the Rating of statistical capacity (0-100) in Overall level in 2010 to that in 2011?
Make the answer very short. 0.95. What is the ratio of the Rating of statistical capacity (0-100) in Methodology assessment in 2010 to that in 2012?
Make the answer very short. 0.8. What is the ratio of the Rating of statistical capacity (0-100) of Overall level in 2010 to that in 2012?
Give a very brief answer. 0.91. What is the ratio of the Rating of statistical capacity (0-100) in Periodicity assessment in 2010 to that in 2012?
Provide a short and direct response. 0.83. What is the ratio of the Rating of statistical capacity (0-100) in Methodology assessment in 2010 to that in 2014?
Provide a short and direct response. 0.67. What is the ratio of the Rating of statistical capacity (0-100) in Overall level in 2010 to that in 2014?
Offer a very short reply. 0.93. What is the ratio of the Rating of statistical capacity (0-100) of Periodicity assessment in 2010 to that in 2014?
Provide a short and direct response. 0.87. What is the ratio of the Rating of statistical capacity (0-100) of Source data assessment in 2010 to that in 2014?
Offer a very short reply. 3. What is the ratio of the Rating of statistical capacity (0-100) of Methodology assessment in 2011 to that in 2012?
Provide a succinct answer. 0.8. What is the ratio of the Rating of statistical capacity (0-100) in Overall level in 2011 to that in 2012?
Provide a short and direct response. 0.96. What is the ratio of the Rating of statistical capacity (0-100) of Overall level in 2011 to that in 2014?
Offer a very short reply. 0.98. What is the ratio of the Rating of statistical capacity (0-100) of Periodicity assessment in 2011 to that in 2014?
Your answer should be very brief. 0.96. What is the ratio of the Rating of statistical capacity (0-100) in Methodology assessment in 2012 to that in 2014?
Keep it short and to the point. 0.83. What is the ratio of the Rating of statistical capacity (0-100) of Overall level in 2012 to that in 2014?
Make the answer very short. 1.02. What is the ratio of the Rating of statistical capacity (0-100) of Periodicity assessment in 2012 to that in 2014?
Provide a short and direct response. 1.04. What is the difference between the highest and the second highest Rating of statistical capacity (0-100) of Overall level?
Offer a terse response. 1.11. What is the difference between the highest and the lowest Rating of statistical capacity (0-100) of Methodology assessment?
Offer a terse response. 20. What is the difference between the highest and the lowest Rating of statistical capacity (0-100) in Overall level?
Ensure brevity in your answer.  7.78. What is the difference between the highest and the lowest Rating of statistical capacity (0-100) in Periodicity assessment?
Make the answer very short. 13.33. 